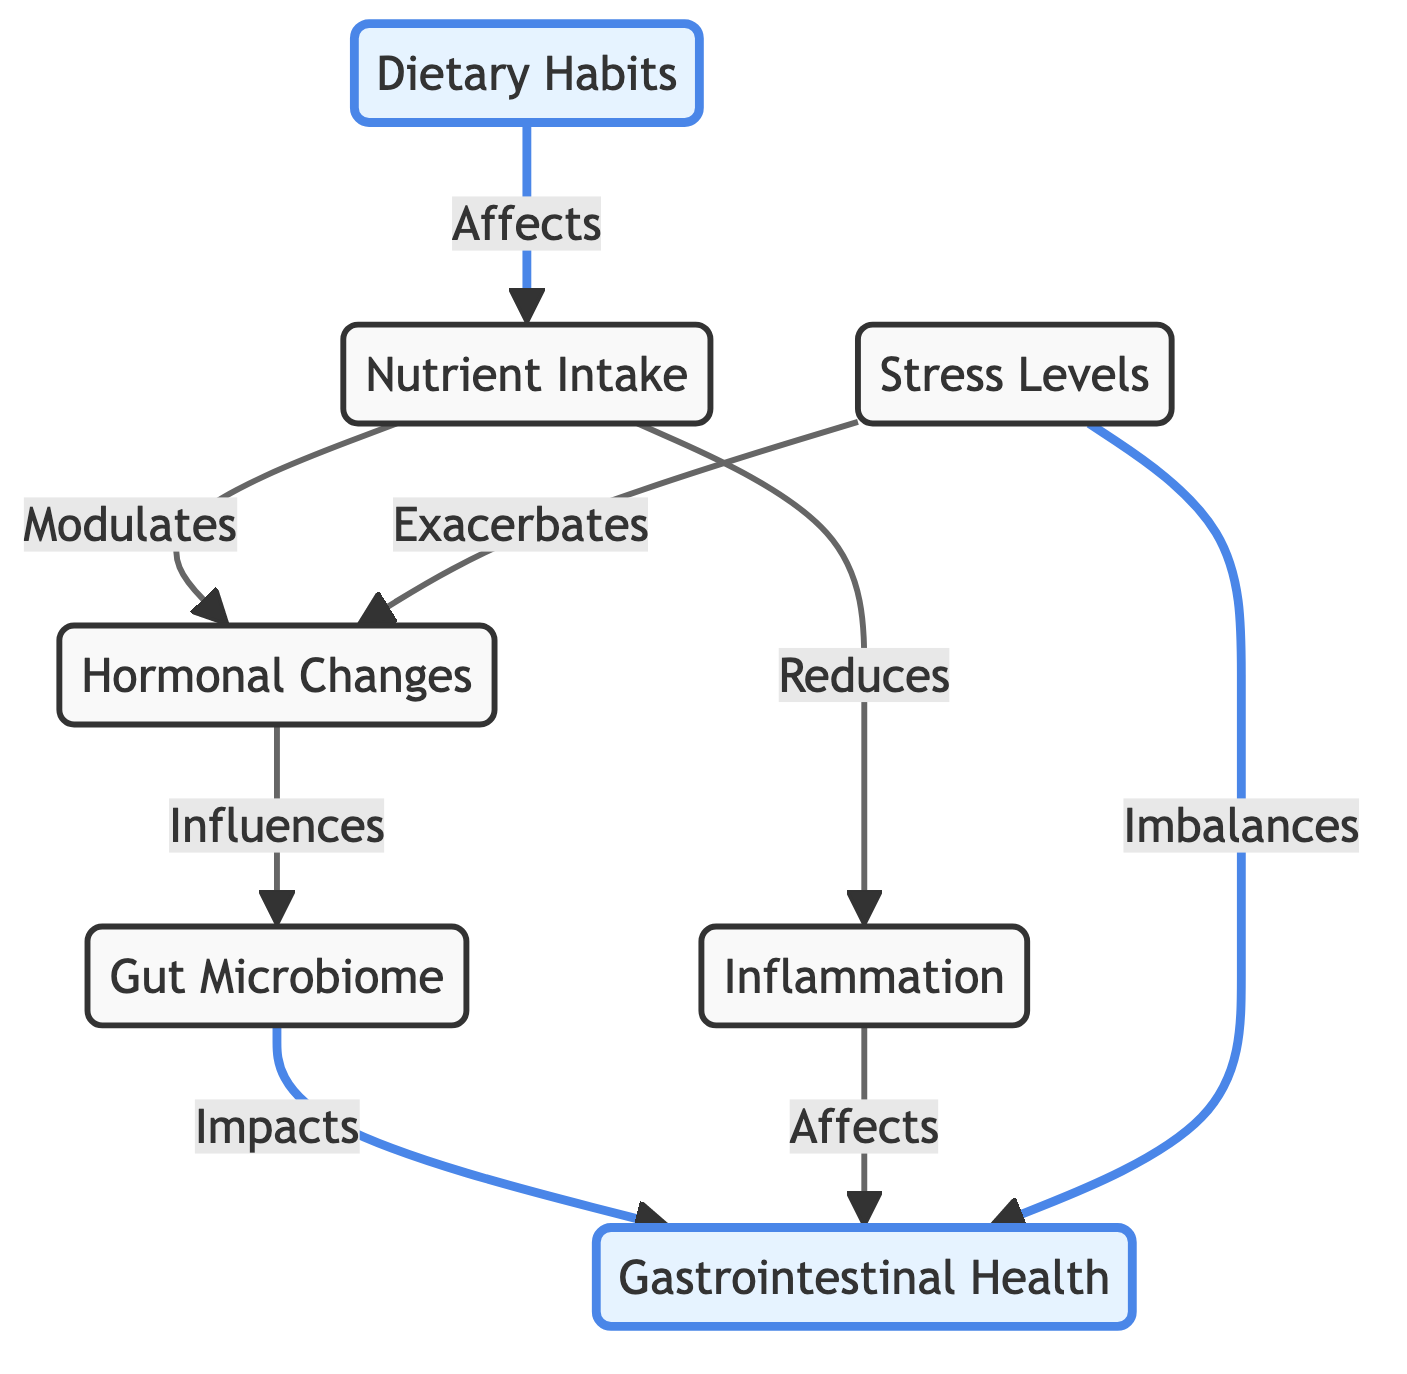What is the first node in the flow diagram? The first node presented in the flow diagram is "Dietary Habits," which initiates the flow of information leading to the other nodes.
Answer: Dietary Habits How many nodes are represented in the diagram? Upon counting the nodes displayed, there are a total of six nodes. These include "Dietary Habits," "Nutrient Intake," "Hormonal Changes," "Gut Microbiome," "Gastrointestinal Health," and "Inflammation."
Answer: Six What does "Nutrient Intake" influence according to the diagram? "Nutrient Intake" influences both "Hormonal Changes" and reduces "Inflammation," showing its critical role in modulating other aspects of health.
Answer: Hormonal Changes and Inflammation What is the relationship between "Stress Levels" and "Gastrointestinal Health"? The diagram indicates that "Stress Levels" can both exacerbate "Hormonal Changes" and imbalance "Gastrointestinal Health," establishing a negative feedback loop.
Answer: Exacerbates and imbalances If "Inflammation" is reduced, what is the effect on "Gastrointestinal Health"? The diagram shows that reducing "Inflammation" positively impacts "Gastrointestinal Health," suggesting a direct beneficial relationship.
Answer: Improves What is the connection between "Hormonal Changes" and "Gut Microbiome"? According to the flow diagram, "Hormonal Changes" influence the "Gut Microbiome," indicating that variations in hormone levels can affect gut bacteria composition.
Answer: Influences How does "Dietary Habits" affect "Gastrointestinal Health"? The diagram outlines that "Dietary Habits" influence "Nutrient Intake," which, in turn, affects "Hormonal Changes" and "Inflammation," ultimately impacting "Gastrointestinal Health."
Answer: Indirectly through Nutrient Intake and Hormonal Changes What role does "Inflammation" have in the flow diagram? "Inflammation" is depicted as a factor that affects "Gastrointestinal Health" by tying together aspects of diet, hormonal changes, and health outcomes, emphasizing its significance in the digestive system's function.
Answer: Affects Gastrointestinal Health 